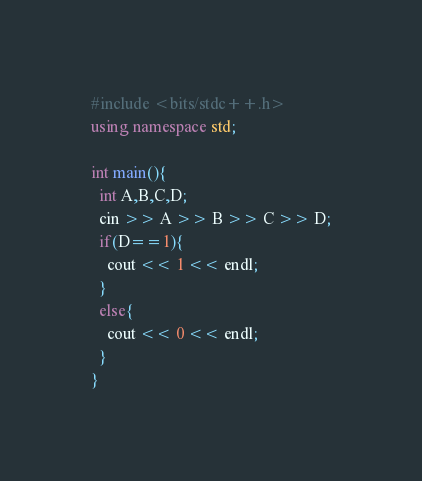<code> <loc_0><loc_0><loc_500><loc_500><_C++_>#include <bits/stdc++.h>
using namespace std;

int main(){
  int A,B,C,D;
  cin >> A >> B >> C >> D;
  if(D==1){
    cout << 1 << endl;
  }
  else{
    cout << 0 << endl;
  }
}</code> 